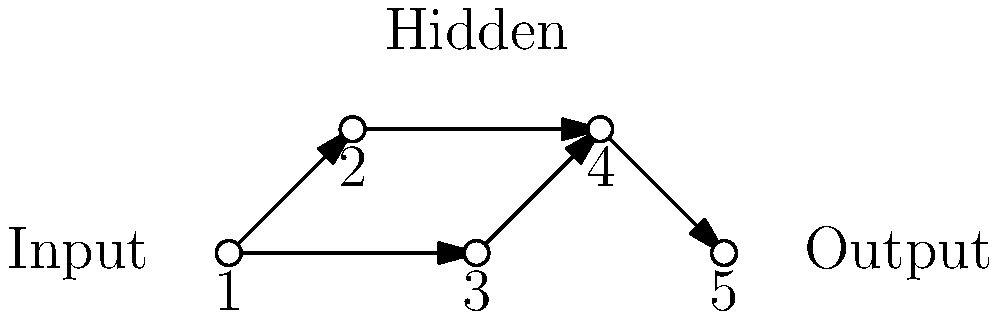In the neural network diagram above, which type of network architecture is represented, and how might this structure be relevant in an AI-driven narrative for a science fiction story? To answer this question, let's analyze the diagram step-by-step:

1. Structure: The diagram shows a network with 5 nodes arranged in 3 layers.
   - Layer 1 (Input): 1 node
   - Layer 2 (Hidden): 3 nodes
   - Layer 3 (Output): 1 node

2. Connections: Each node is connected to all nodes in the next layer, but there are no connections within the same layer or to previous layers.

3. Network type: This structure represents a feedforward neural network, specifically a multi-layer perceptron (MLP).

4. Relevance in AI-driven narrative:
   a) Simple decision-making: This network could represent a basic AI system capable of making simple decisions based on input data.
   b) Pattern recognition: The hidden layer allows for more complex pattern recognition than a single-layer network.
   c) Non-linear problem solving: MLPs can approximate non-linear functions, making them suitable for complex problem-solving in a sci-fi context.
   d) Scalability: The structure can be expanded to handle more complex tasks by adding more nodes and layers.
   e) Basis for more advanced AI: This network could serve as a building block for more sophisticated AI systems in the story.

In a science fiction story, this network could be used to illustrate:
- The foundational architecture of an AI character's "brain"
- A component of a larger, more complex robotic system
- The starting point for an AI's evolution throughout the narrative
Answer: Feedforward neural network (Multi-layer perceptron); represents basic AI decision-making, pattern recognition, and problem-solving capabilities in a sci-fi narrative. 